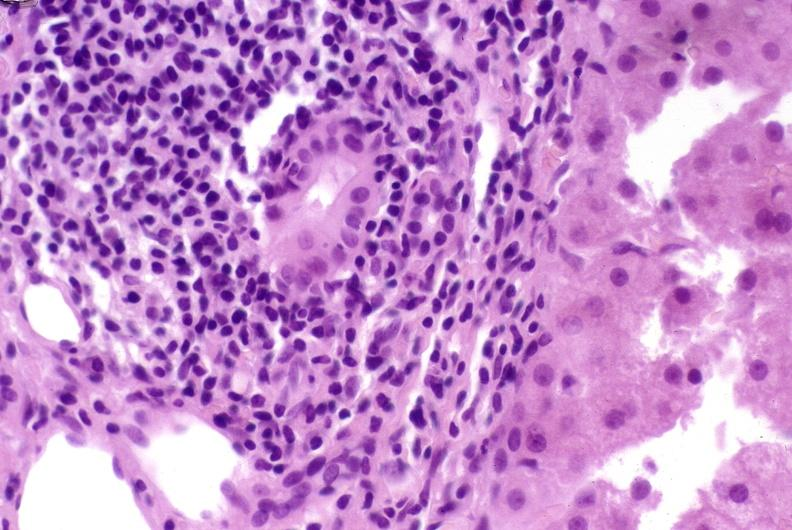does this image show post-orthotopic liver transplant?
Answer the question using a single word or phrase. Yes 